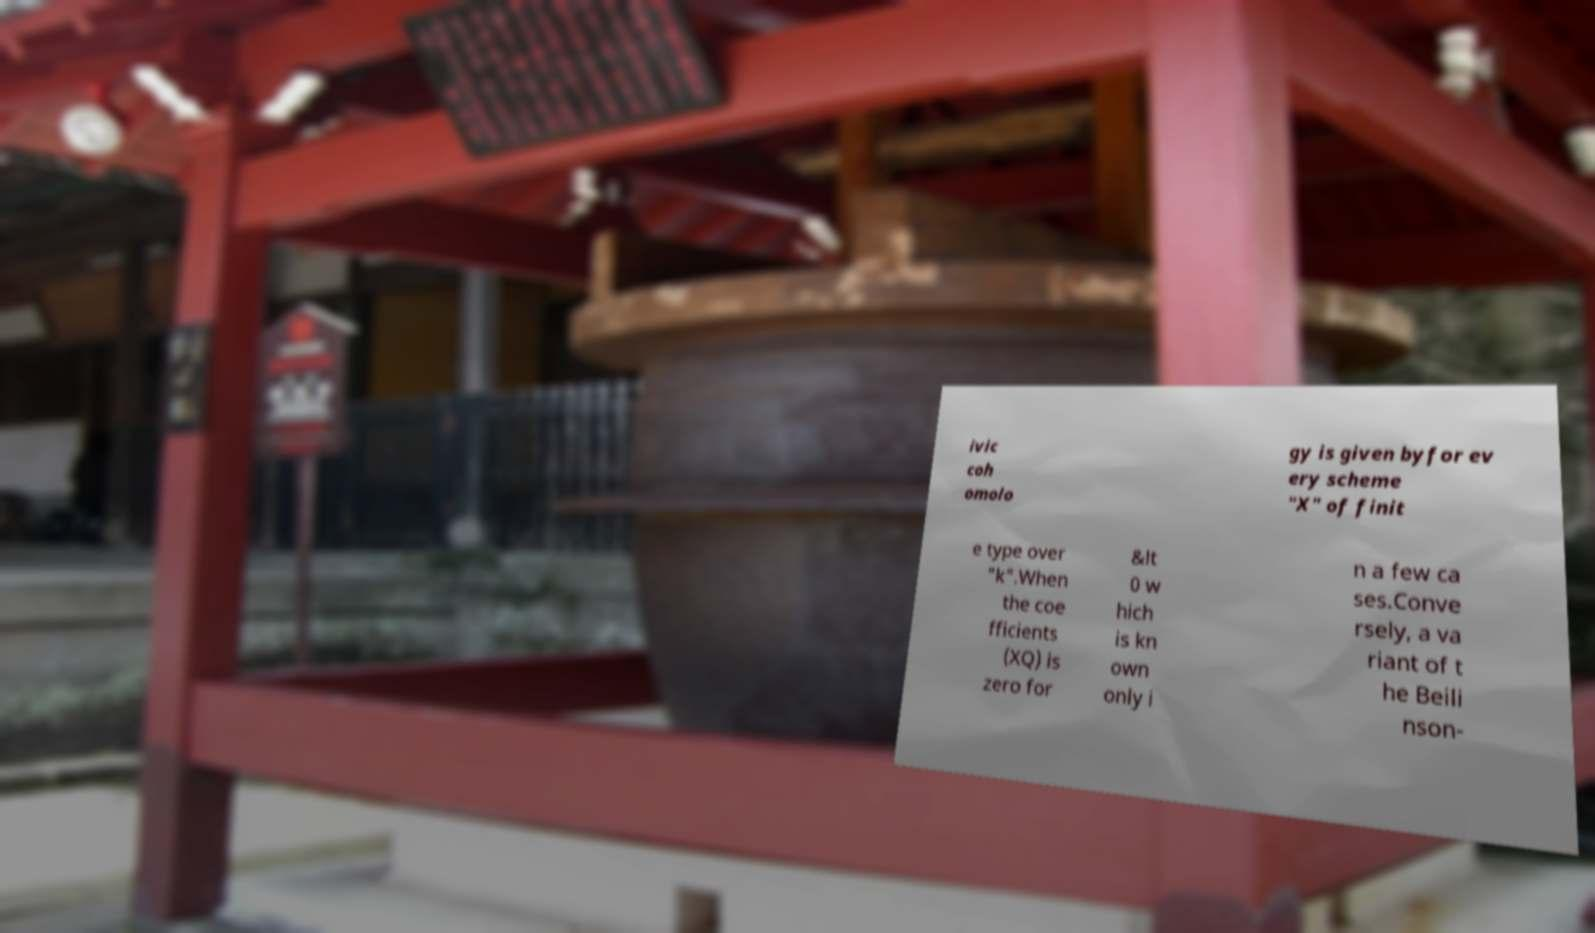There's text embedded in this image that I need extracted. Can you transcribe it verbatim? ivic coh omolo gy is given byfor ev ery scheme "X" of finit e type over "k".When the coe fficients (XQ) is zero for &lt 0 w hich is kn own only i n a few ca ses.Conve rsely, a va riant of t he Beili nson- 